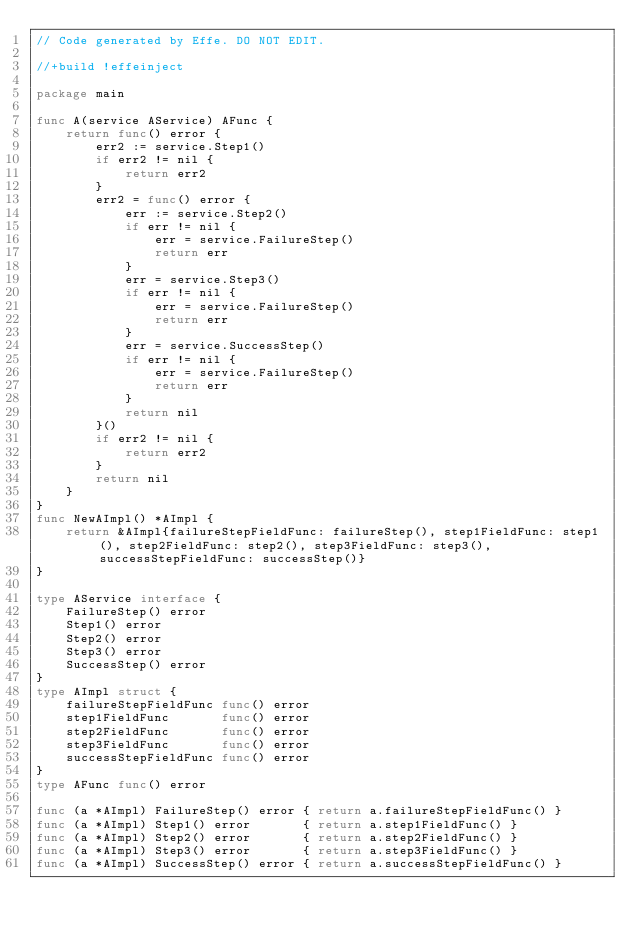Convert code to text. <code><loc_0><loc_0><loc_500><loc_500><_Go_>// Code generated by Effe. DO NOT EDIT.

//+build !effeinject

package main

func A(service AService) AFunc {
	return func() error {
		err2 := service.Step1()
		if err2 != nil {
			return err2
		}
		err2 = func() error {
			err := service.Step2()
			if err != nil {
				err = service.FailureStep()
				return err
			}
			err = service.Step3()
			if err != nil {
				err = service.FailureStep()
				return err
			}
			err = service.SuccessStep()
			if err != nil {
				err = service.FailureStep()
				return err
			}
			return nil
		}()
		if err2 != nil {
			return err2
		}
		return nil
	}
}
func NewAImpl() *AImpl {
	return &AImpl{failureStepFieldFunc: failureStep(), step1FieldFunc: step1(), step2FieldFunc: step2(), step3FieldFunc: step3(), successStepFieldFunc: successStep()}
}

type AService interface {
	FailureStep() error
	Step1() error
	Step2() error
	Step3() error
	SuccessStep() error
}
type AImpl struct {
	failureStepFieldFunc func() error
	step1FieldFunc       func() error
	step2FieldFunc       func() error
	step3FieldFunc       func() error
	successStepFieldFunc func() error
}
type AFunc func() error

func (a *AImpl) FailureStep() error { return a.failureStepFieldFunc() }
func (a *AImpl) Step1() error       { return a.step1FieldFunc() }
func (a *AImpl) Step2() error       { return a.step2FieldFunc() }
func (a *AImpl) Step3() error       { return a.step3FieldFunc() }
func (a *AImpl) SuccessStep() error { return a.successStepFieldFunc() }
</code> 